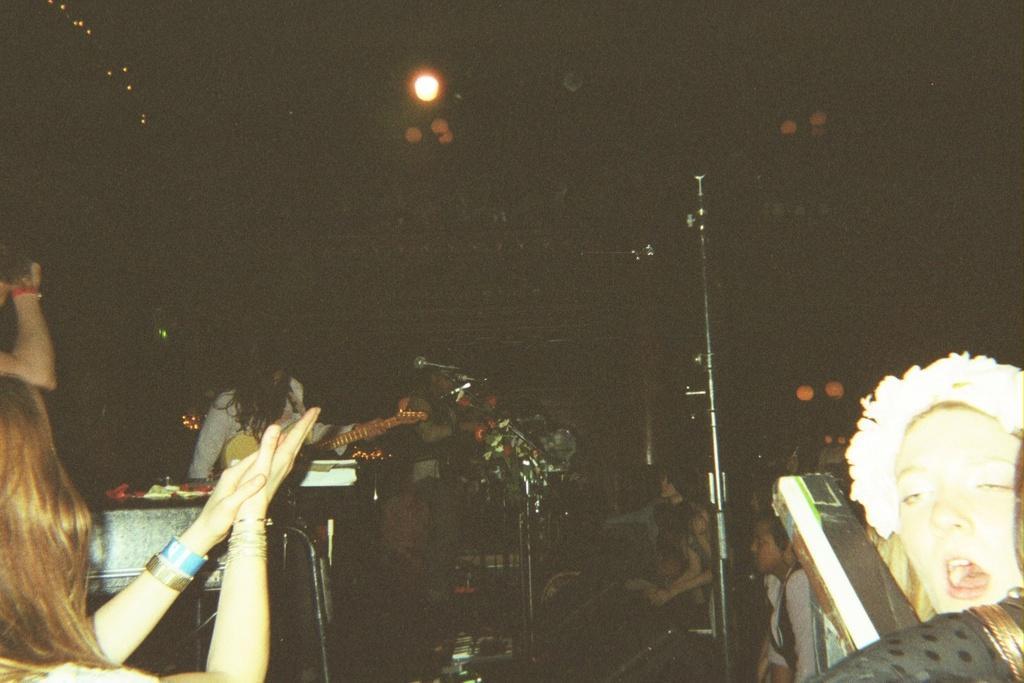Please provide a concise description of this image. To the bottom left of the image there is a person sitting and clapping. To the right bottom corner of the image there is another person. In the middle of the image there are few people playing musical instruments. There is a black background. And to the top of the image there is a light in the middle. 